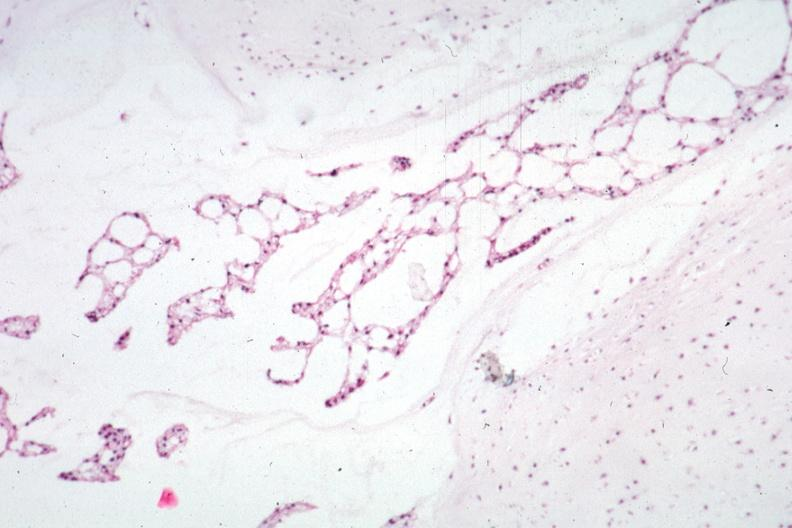s notochord present?
Answer the question using a single word or phrase. Yes 